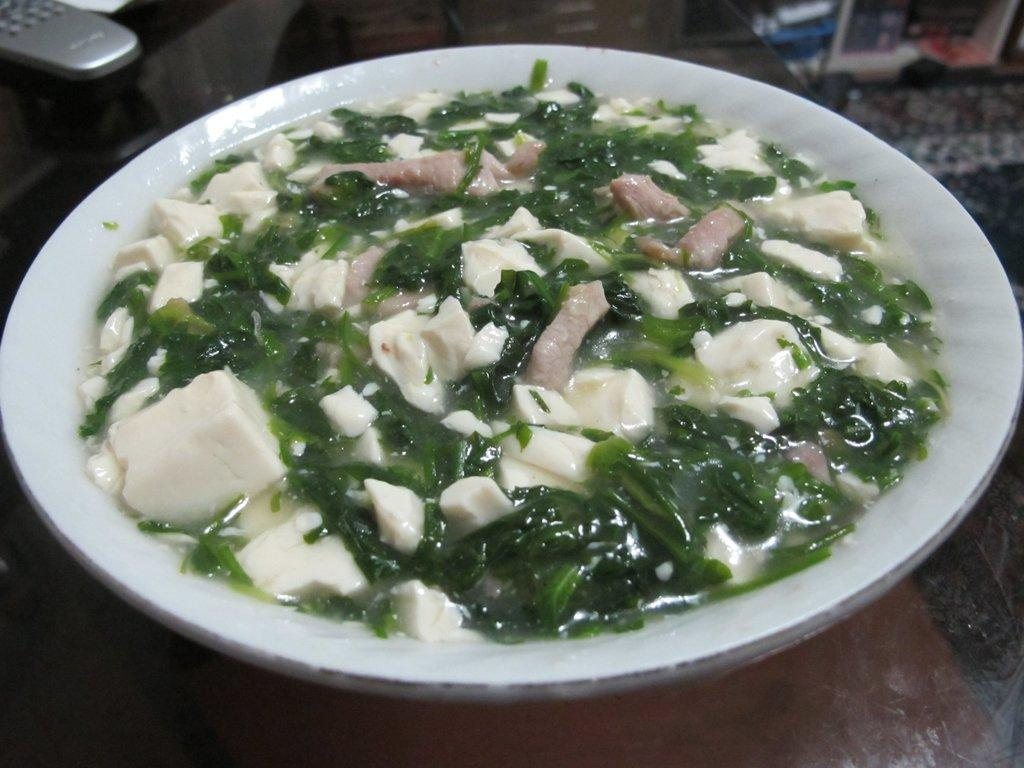What is on the plate that is visible in the image? There is a plate with food in the image. What other object can be seen on the glass table? There is a remote on the glass table in the image. What type of veil is draped over the plate of food in the image? There is no veil present in the image; the plate of food is visible without any covering. 